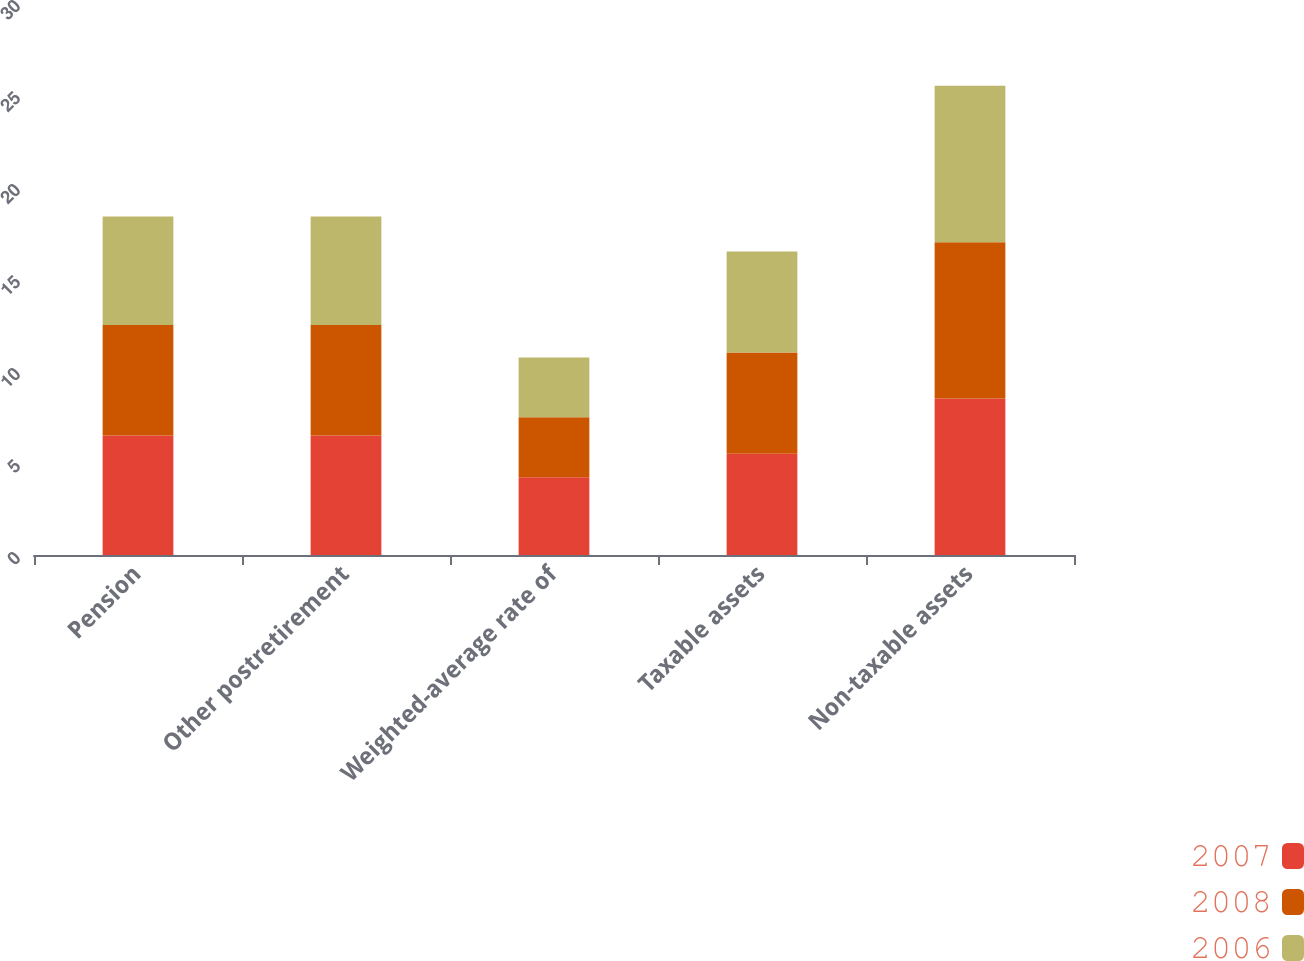<chart> <loc_0><loc_0><loc_500><loc_500><stacked_bar_chart><ecel><fcel>Pension<fcel>Other postretirement<fcel>Weighted-average rate of<fcel>Taxable assets<fcel>Non-taxable assets<nl><fcel>2007<fcel>6.5<fcel>6.5<fcel>4.23<fcel>5.5<fcel>8.5<nl><fcel>2008<fcel>6<fcel>6<fcel>3.25<fcel>5.5<fcel>8.5<nl><fcel>2006<fcel>5.9<fcel>5.9<fcel>3.25<fcel>5.5<fcel>8.5<nl></chart> 